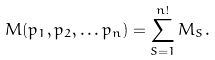<formula> <loc_0><loc_0><loc_500><loc_500>M ( p _ { 1 } , p _ { 2 } , \dots p _ { n } ) = \sum _ { S = 1 } ^ { n ! } M _ { S } .</formula> 